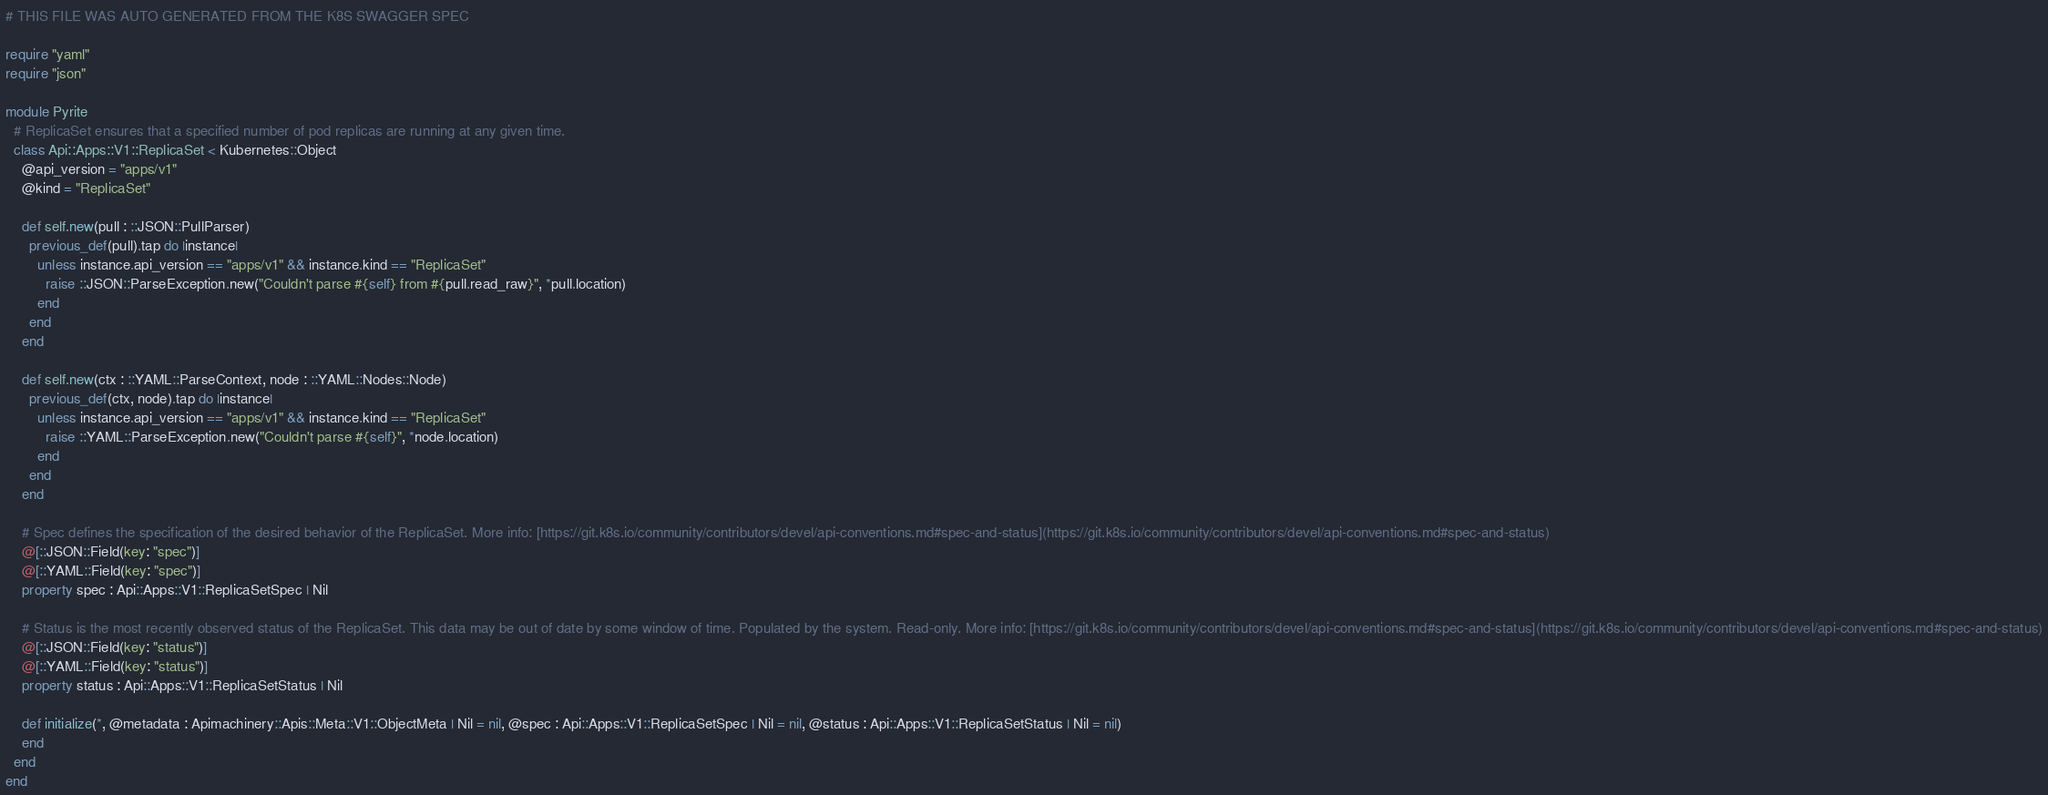<code> <loc_0><loc_0><loc_500><loc_500><_Crystal_># THIS FILE WAS AUTO GENERATED FROM THE K8S SWAGGER SPEC

require "yaml"
require "json"

module Pyrite
  # ReplicaSet ensures that a specified number of pod replicas are running at any given time.
  class Api::Apps::V1::ReplicaSet < Kubernetes::Object
    @api_version = "apps/v1"
    @kind = "ReplicaSet"

    def self.new(pull : ::JSON::PullParser)
      previous_def(pull).tap do |instance|
        unless instance.api_version == "apps/v1" && instance.kind == "ReplicaSet"
          raise ::JSON::ParseException.new("Couldn't parse #{self} from #{pull.read_raw}", *pull.location)
        end
      end
    end

    def self.new(ctx : ::YAML::ParseContext, node : ::YAML::Nodes::Node)
      previous_def(ctx, node).tap do |instance|
        unless instance.api_version == "apps/v1" && instance.kind == "ReplicaSet"
          raise ::YAML::ParseException.new("Couldn't parse #{self}", *node.location)
        end
      end
    end

    # Spec defines the specification of the desired behavior of the ReplicaSet. More info: [https://git.k8s.io/community/contributors/devel/api-conventions.md#spec-and-status](https://git.k8s.io/community/contributors/devel/api-conventions.md#spec-and-status)
    @[::JSON::Field(key: "spec")]
    @[::YAML::Field(key: "spec")]
    property spec : Api::Apps::V1::ReplicaSetSpec | Nil

    # Status is the most recently observed status of the ReplicaSet. This data may be out of date by some window of time. Populated by the system. Read-only. More info: [https://git.k8s.io/community/contributors/devel/api-conventions.md#spec-and-status](https://git.k8s.io/community/contributors/devel/api-conventions.md#spec-and-status)
    @[::JSON::Field(key: "status")]
    @[::YAML::Field(key: "status")]
    property status : Api::Apps::V1::ReplicaSetStatus | Nil

    def initialize(*, @metadata : Apimachinery::Apis::Meta::V1::ObjectMeta | Nil = nil, @spec : Api::Apps::V1::ReplicaSetSpec | Nil = nil, @status : Api::Apps::V1::ReplicaSetStatus | Nil = nil)
    end
  end
end
</code> 